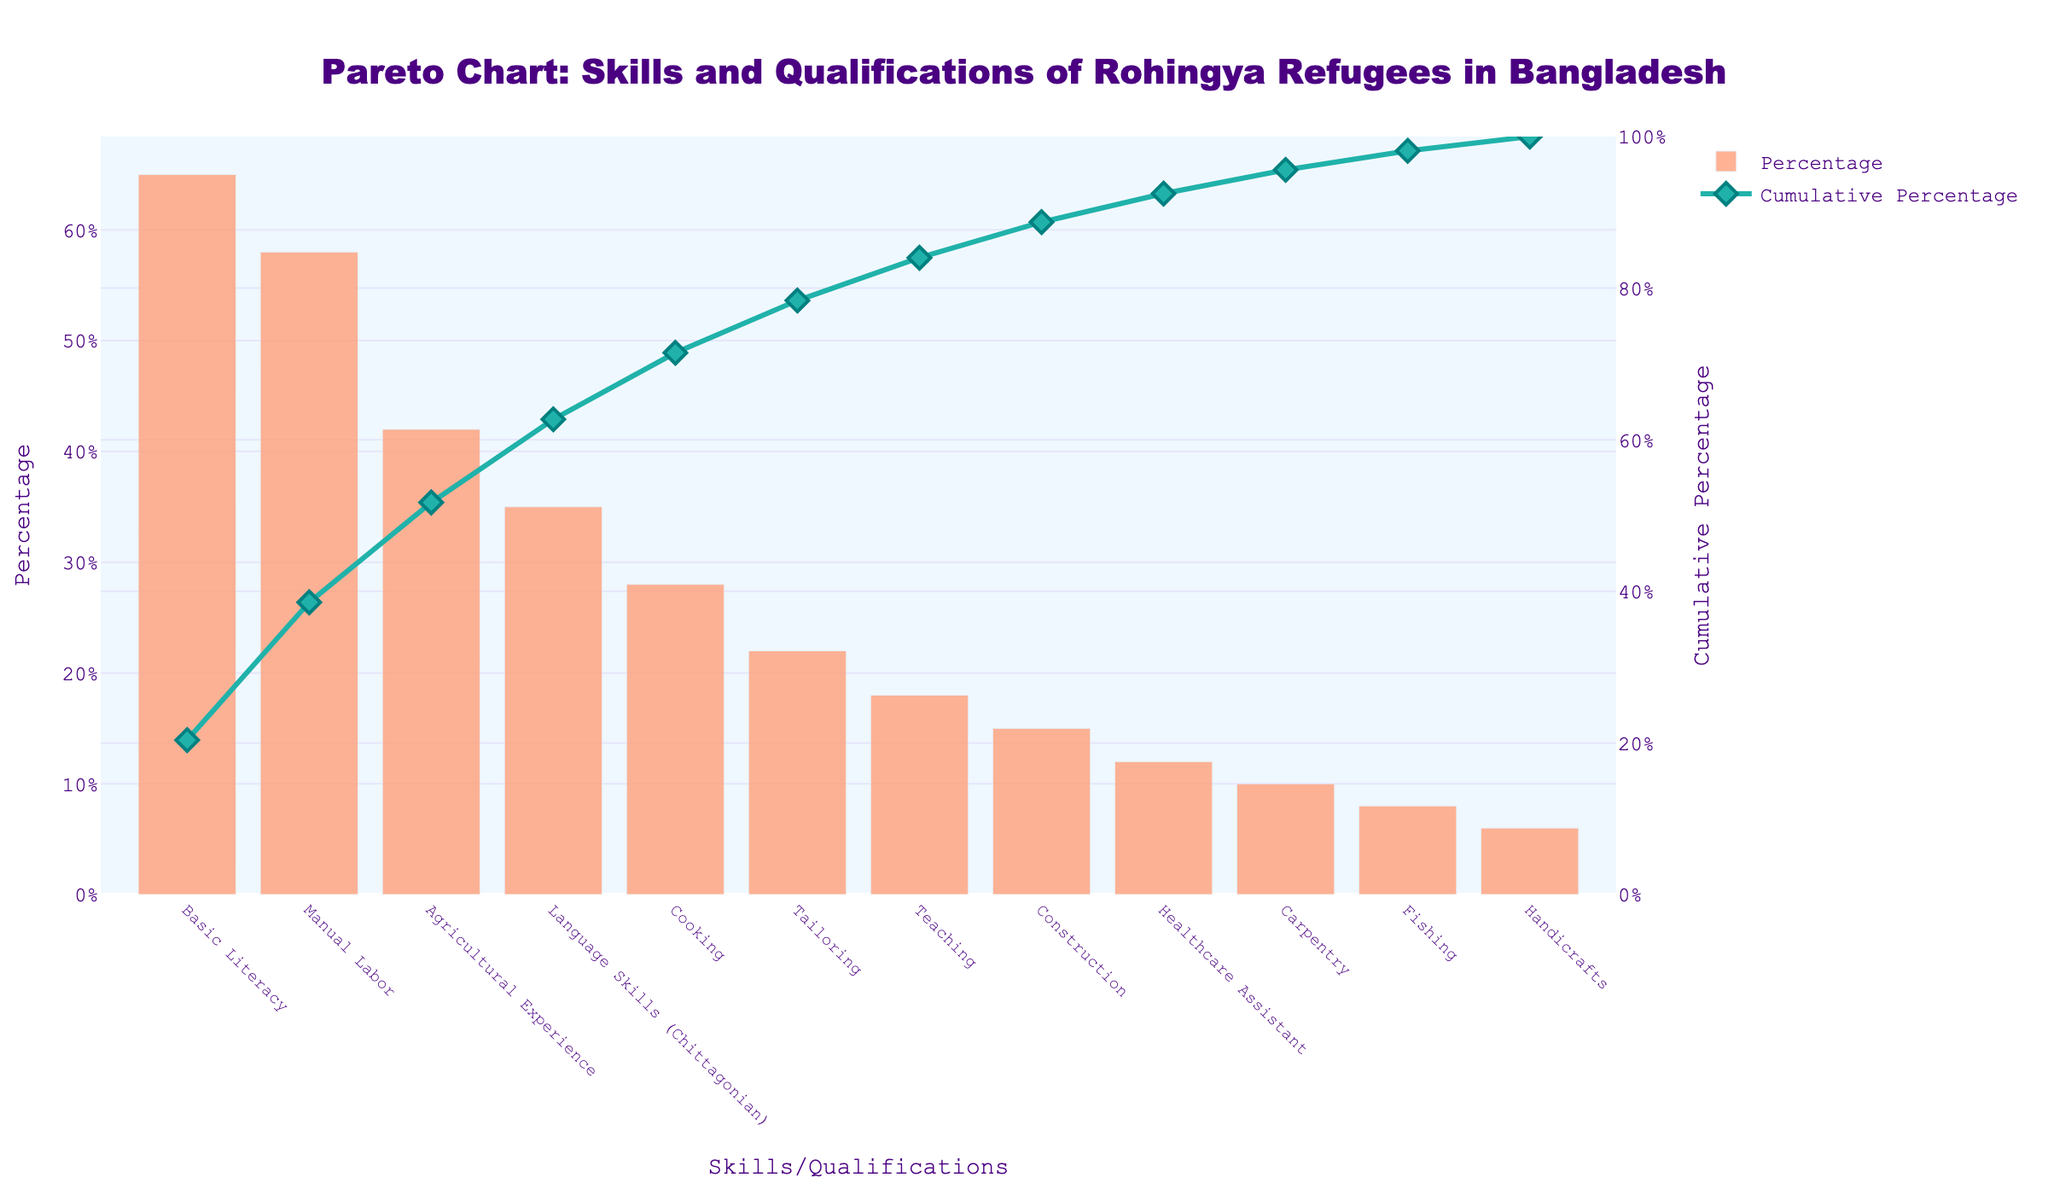What is the title of the figure? The title is typically displayed at the top of the figure. In this case, it reads "Pareto Chart: Skills and Qualifications of Rohingya Refugees in Bangladesh".
Answer: Pareto Chart: Skills and Qualifications of Rohingya Refugees in Bangladesh Which skill/qualification has the highest percentage among Rohingya refugees? To determine this, observe the tallest bar in the bar chart. The bar labeled "Basic Literacy" is the tallest, indicating the highest percentage.
Answer: Basic Literacy What is the cumulative percentage at the "Language Skills (Chittagonian)" category? On the Pareto chart, trace the value of the cumulative percentage line at the point corresponding to "Language Skills (Chittagonian)". The line intersects at 85%.
Answer: 85% How many skills/qualifications have a percentage greater than 30%? Count the number of bars that are taller than the 30% mark. The skills "Basic Literacy", "Manual Labor", "Agricultural Experience", and "Language Skills (Chittagonian)" are above 30%. There are 4 such skills.
Answer: 4 Which skill has the lowest percentage? Identify the shortest bar on the chart, which represents the skill with the lowest percentage. The "Handicrafts" bar is the shortest at 6%.
Answer: Handicrafts What is the percentage difference between "Teaching" and "Construction" skills? Subtract the percentage of "Construction" from the percentage of "Teaching". "Teaching" is 18% and "Construction" is 15%. So, 18% - 15% = 3%.
Answer: 3% How many skills/qualifications cumulatively account for more than 50% of the total? Follow the cumulative percentage line until it exceeds 50%, and count the corresponding bars. "Basic Literacy" and "Manual Labor" together exceed 50%.
Answer: 2 Which skills account for at least 75% of the cumulative percentage? Trace the cumulative percentage line until it reaches 75%, then list the skills up to that point. "Basic Literacy", "Manual Labor", "Agricultural Experience", and "Language Skills (Chittagonian)" together exceed 75%.
Answer: Basic Literacy, Manual Labor, Agricultural Experience, Language Skills (Chittagonian) What is the percentage sum of "Tailoring", "Teaching", and "Construction"? Add the percentages of these three skills. "Tailoring" is 22%, "Teaching" is 18%, and "Construction" is 15%. So, 22% + 18% + 15% = 55%.
Answer: 55% 